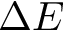<formula> <loc_0><loc_0><loc_500><loc_500>\Delta E</formula> 